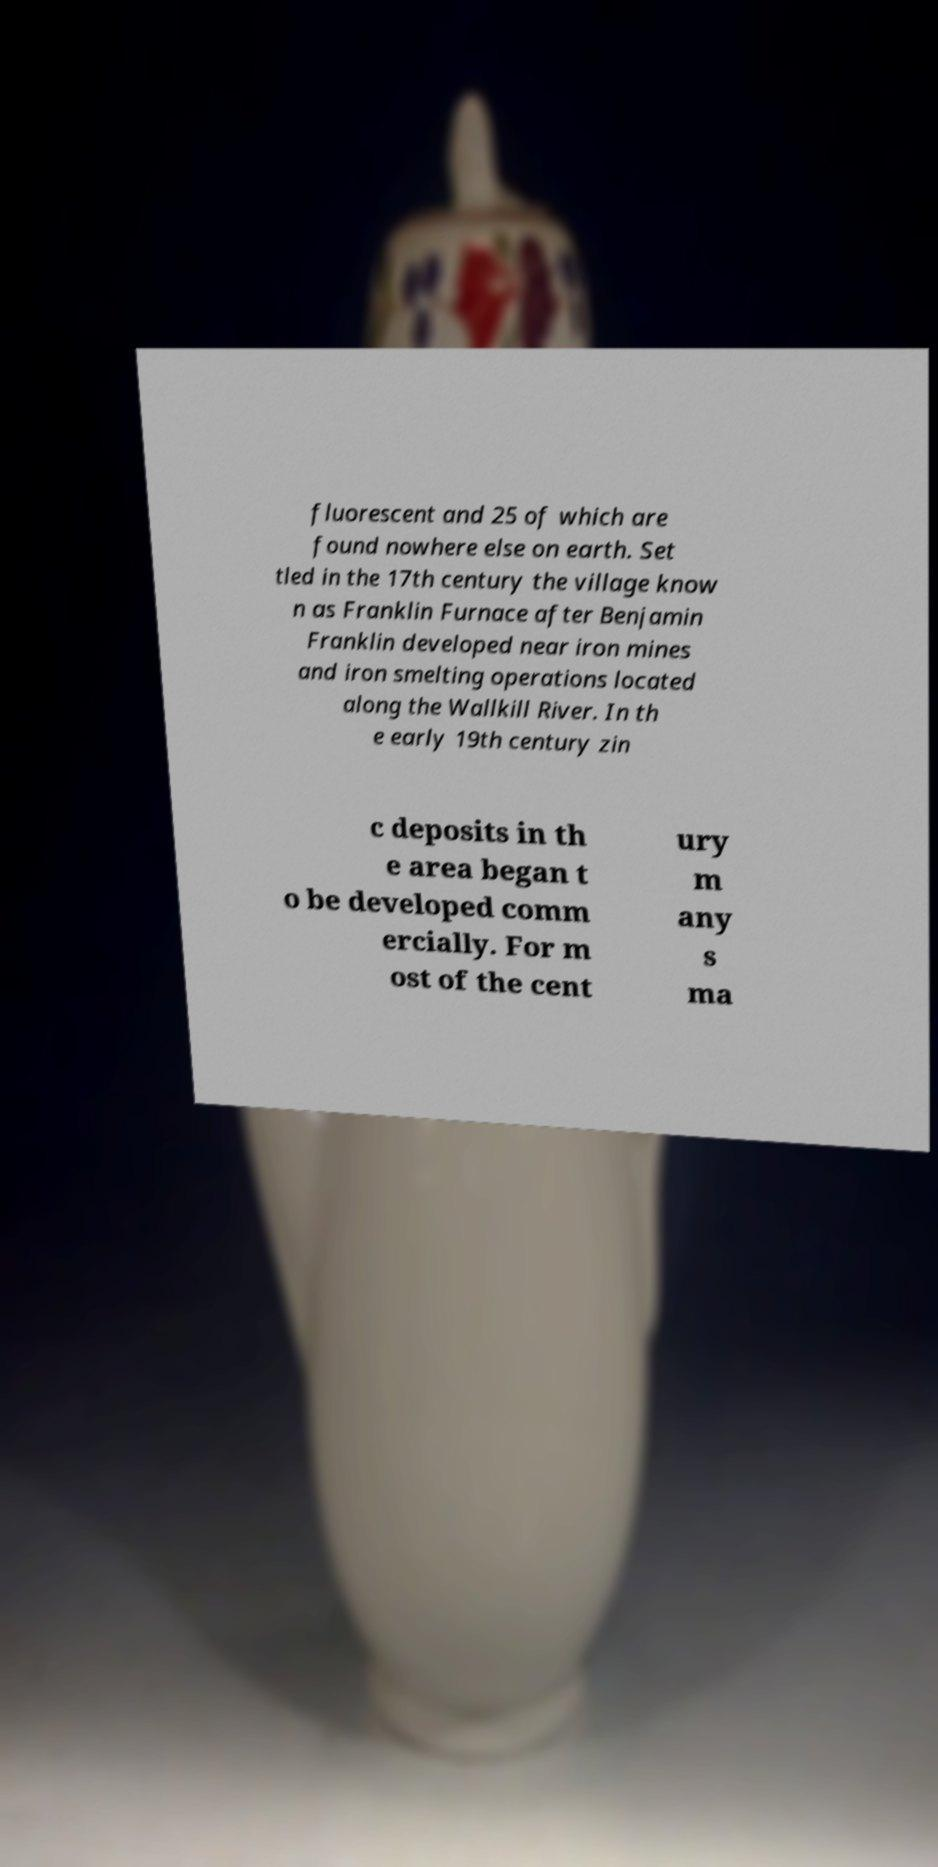Can you read and provide the text displayed in the image?This photo seems to have some interesting text. Can you extract and type it out for me? fluorescent and 25 of which are found nowhere else on earth. Set tled in the 17th century the village know n as Franklin Furnace after Benjamin Franklin developed near iron mines and iron smelting operations located along the Wallkill River. In th e early 19th century zin c deposits in th e area began t o be developed comm ercially. For m ost of the cent ury m any s ma 